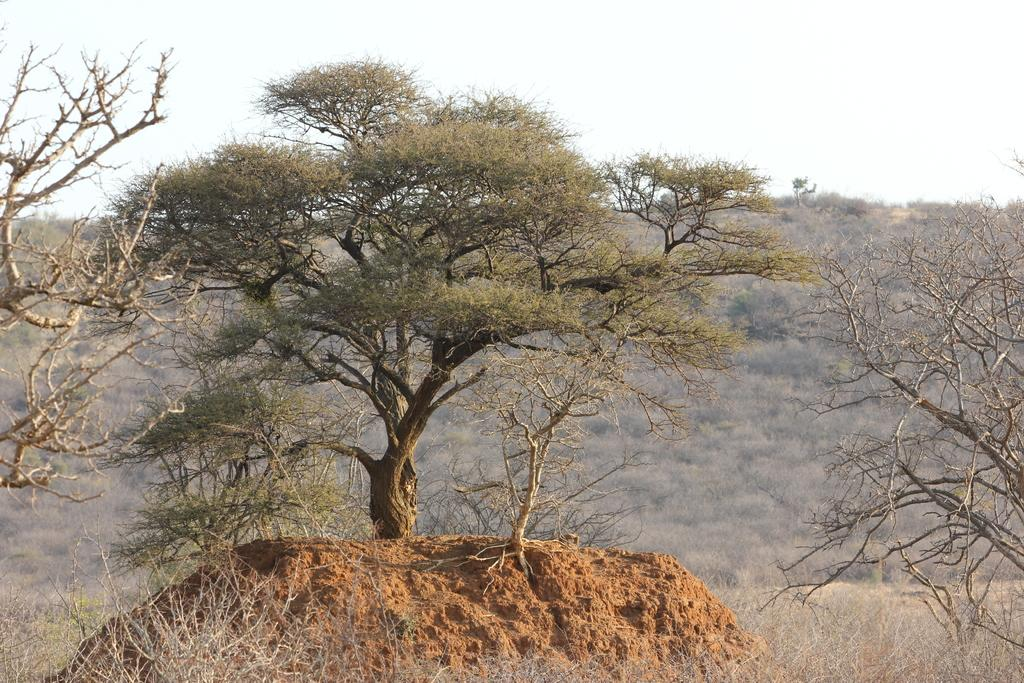What type of plant can be seen in the image? There is a tree in the image. What geological feature is present in the image? There is a mud mountain in the image. What is the color of the sky in the image? The sky is white in color. What type of vegetation is visible in front of the tree and mud mountain? Dry grass is visible in front of the tree and mud mountain. What type of flesh can be seen on the tree in the image? There is no flesh present on the tree in the image; it is a plant. How many eggs are visible in the image? There are no eggs present in the image. 